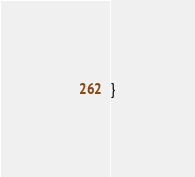Convert code to text. <code><loc_0><loc_0><loc_500><loc_500><_JavaScript_>}
</code> 